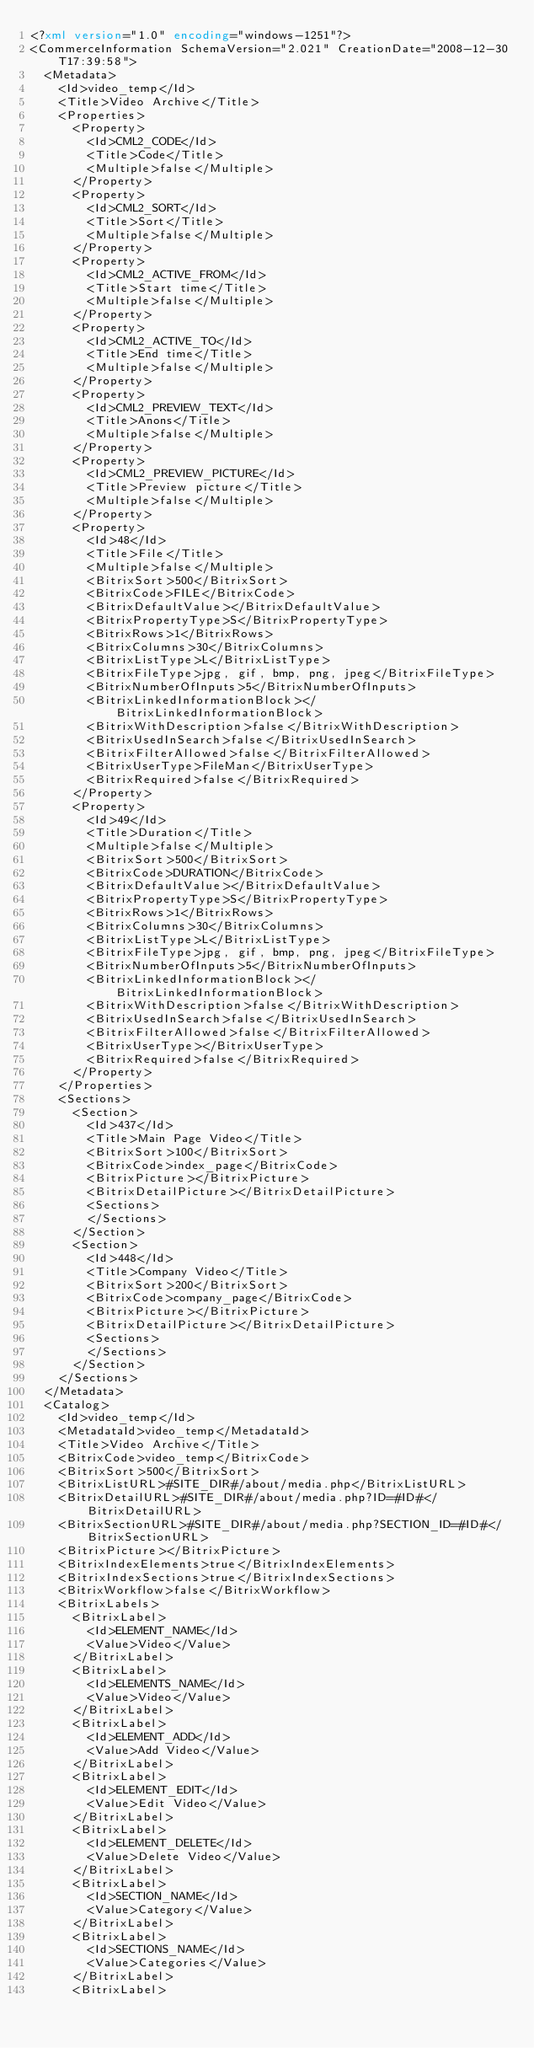Convert code to text. <code><loc_0><loc_0><loc_500><loc_500><_XML_><?xml version="1.0" encoding="windows-1251"?>
<CommerceInformation SchemaVersion="2.021" CreationDate="2008-12-30T17:39:58">
	<Metadata>
		<Id>video_temp</Id>
		<Title>Video Archive</Title>
		<Properties>
			<Property>
				<Id>CML2_CODE</Id>
				<Title>Code</Title>
				<Multiple>false</Multiple>
			</Property>
			<Property>
				<Id>CML2_SORT</Id>
				<Title>Sort</Title>
				<Multiple>false</Multiple>
			</Property>
			<Property>
				<Id>CML2_ACTIVE_FROM</Id>
				<Title>Start time</Title>
				<Multiple>false</Multiple>
			</Property>
			<Property>
				<Id>CML2_ACTIVE_TO</Id>
				<Title>End time</Title>
				<Multiple>false</Multiple>
			</Property>
			<Property>
				<Id>CML2_PREVIEW_TEXT</Id>
				<Title>Anons</Title>
				<Multiple>false</Multiple>
			</Property>
			<Property>
				<Id>CML2_PREVIEW_PICTURE</Id>
				<Title>Preview picture</Title>
				<Multiple>false</Multiple>
			</Property>
			<Property>
				<Id>48</Id>
				<Title>File</Title>
				<Multiple>false</Multiple>
				<BitrixSort>500</BitrixSort>
				<BitrixCode>FILE</BitrixCode>
				<BitrixDefaultValue></BitrixDefaultValue>
				<BitrixPropertyType>S</BitrixPropertyType>
				<BitrixRows>1</BitrixRows>
				<BitrixColumns>30</BitrixColumns>
				<BitrixListType>L</BitrixListType>
				<BitrixFileType>jpg, gif, bmp, png, jpeg</BitrixFileType>
				<BitrixNumberOfInputs>5</BitrixNumberOfInputs>
				<BitrixLinkedInformationBlock></BitrixLinkedInformationBlock>
				<BitrixWithDescription>false</BitrixWithDescription>
				<BitrixUsedInSearch>false</BitrixUsedInSearch>
				<BitrixFilterAllowed>false</BitrixFilterAllowed>
				<BitrixUserType>FileMan</BitrixUserType>
				<BitrixRequired>false</BitrixRequired>
			</Property>
			<Property>
				<Id>49</Id>
				<Title>Duration</Title>
				<Multiple>false</Multiple>
				<BitrixSort>500</BitrixSort>
				<BitrixCode>DURATION</BitrixCode>
				<BitrixDefaultValue></BitrixDefaultValue>
				<BitrixPropertyType>S</BitrixPropertyType>
				<BitrixRows>1</BitrixRows>
				<BitrixColumns>30</BitrixColumns>
				<BitrixListType>L</BitrixListType>
				<BitrixFileType>jpg, gif, bmp, png, jpeg</BitrixFileType>
				<BitrixNumberOfInputs>5</BitrixNumberOfInputs>
				<BitrixLinkedInformationBlock></BitrixLinkedInformationBlock>
				<BitrixWithDescription>false</BitrixWithDescription>
				<BitrixUsedInSearch>false</BitrixUsedInSearch>
				<BitrixFilterAllowed>false</BitrixFilterAllowed>
				<BitrixUserType></BitrixUserType>
				<BitrixRequired>false</BitrixRequired>
			</Property>
		</Properties>
		<Sections>
			<Section>
				<Id>437</Id>
				<Title>Main Page Video</Title>
				<BitrixSort>100</BitrixSort>
				<BitrixCode>index_page</BitrixCode>
				<BitrixPicture></BitrixPicture>
				<BitrixDetailPicture></BitrixDetailPicture>
				<Sections>
				</Sections>
			</Section>
			<Section>
				<Id>448</Id>
				<Title>Company Video</Title>
				<BitrixSort>200</BitrixSort>
				<BitrixCode>company_page</BitrixCode>
				<BitrixPicture></BitrixPicture>
				<BitrixDetailPicture></BitrixDetailPicture>
				<Sections>
				</Sections>
			</Section>
		</Sections>
	</Metadata>
	<Catalog>
		<Id>video_temp</Id>
		<MetadataId>video_temp</MetadataId>
		<Title>Video Archive</Title>
		<BitrixCode>video_temp</BitrixCode>
		<BitrixSort>500</BitrixSort>
		<BitrixListURL>#SITE_DIR#/about/media.php</BitrixListURL>
		<BitrixDetailURL>#SITE_DIR#/about/media.php?ID=#ID#</BitrixDetailURL>
		<BitrixSectionURL>#SITE_DIR#/about/media.php?SECTION_ID=#ID#</BitrixSectionURL>
		<BitrixPicture></BitrixPicture>
		<BitrixIndexElements>true</BitrixIndexElements>
		<BitrixIndexSections>true</BitrixIndexSections>
		<BitrixWorkflow>false</BitrixWorkflow>
		<BitrixLabels>
			<BitrixLabel>
				<Id>ELEMENT_NAME</Id>
				<Value>Video</Value>
			</BitrixLabel>
			<BitrixLabel>
				<Id>ELEMENTS_NAME</Id>
				<Value>Video</Value>
			</BitrixLabel>
			<BitrixLabel>
				<Id>ELEMENT_ADD</Id>
				<Value>Add Video</Value>
			</BitrixLabel>
			<BitrixLabel>
				<Id>ELEMENT_EDIT</Id>
				<Value>Edit Video</Value>
			</BitrixLabel>
			<BitrixLabel>
				<Id>ELEMENT_DELETE</Id>
				<Value>Delete Video</Value>
			</BitrixLabel>
			<BitrixLabel>
				<Id>SECTION_NAME</Id>
				<Value>Category</Value>
			</BitrixLabel>
			<BitrixLabel>
				<Id>SECTIONS_NAME</Id>
				<Value>Categories</Value>
			</BitrixLabel>
			<BitrixLabel></code> 